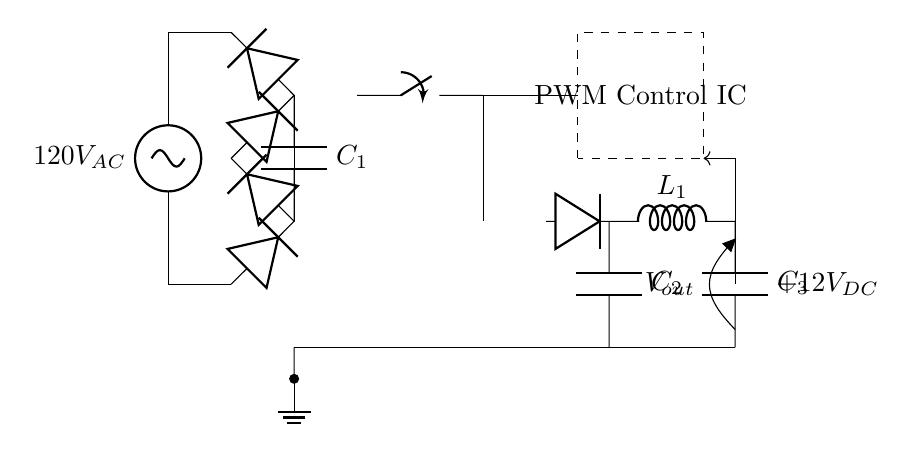What is the input voltage of the circuit? The input voltage is 120 volts AC, which is indicated at the beginning of the circuit diagram next to the AC source label.
Answer: 120V AC What is the role of the smoothing capacitor in this circuit? The smoothing capacitor (C1) helps to reduce ripple in the output voltage after rectification, ensuring that the DC output is smoother and more stable.
Answer: Smoothing How many diodes are present in the bridge rectifier? The bridge rectifier has four diodes, as indicated by the two pairs depicted in a diamond configuration in the circuit.
Answer: Four What type of output voltage does the circuit provide? The output voltage marked in the circuit is +12 volts DC, which is derived from the rectification and smoothing process.
Answer: +12V DC What component is responsible for voltage regulation? The PWM Control IC manages the output voltage by controlling the switching devices in the power supply circuit, making it the regulator in this context.
Answer: PWM Control IC What is the purpose of the transformer in the circuit? The transformer steps down the high AC voltage to a lower AC voltage suitable for rectification and further processing, which is crucial for the power supply circuitry.
Answer: Step down How is feedback implemented in this circuit? Feedback is implemented through a line connecting the output back to the control IC; this allows the control IC to adjust the output voltage based on the feedback it receives.
Answer: Feedback line 